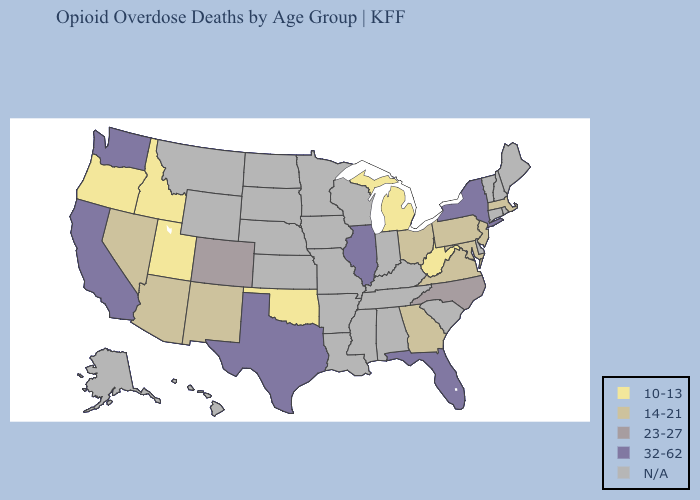Which states have the highest value in the USA?
Concise answer only. California, Florida, Illinois, New York, Texas, Washington. What is the highest value in states that border Idaho?
Be succinct. 32-62. What is the highest value in the South ?
Give a very brief answer. 32-62. Does Oregon have the lowest value in the USA?
Keep it brief. Yes. What is the highest value in the West ?
Short answer required. 32-62. Name the states that have a value in the range 23-27?
Write a very short answer. Colorado, North Carolina. Name the states that have a value in the range N/A?
Short answer required. Alabama, Alaska, Arkansas, Connecticut, Delaware, Hawaii, Indiana, Iowa, Kansas, Kentucky, Louisiana, Maine, Minnesota, Mississippi, Missouri, Montana, Nebraska, New Hampshire, North Dakota, Rhode Island, South Carolina, South Dakota, Tennessee, Vermont, Wisconsin, Wyoming. Is the legend a continuous bar?
Answer briefly. No. Name the states that have a value in the range 10-13?
Concise answer only. Idaho, Michigan, Oklahoma, Oregon, Utah, West Virginia. What is the value of Maryland?
Short answer required. 14-21. 